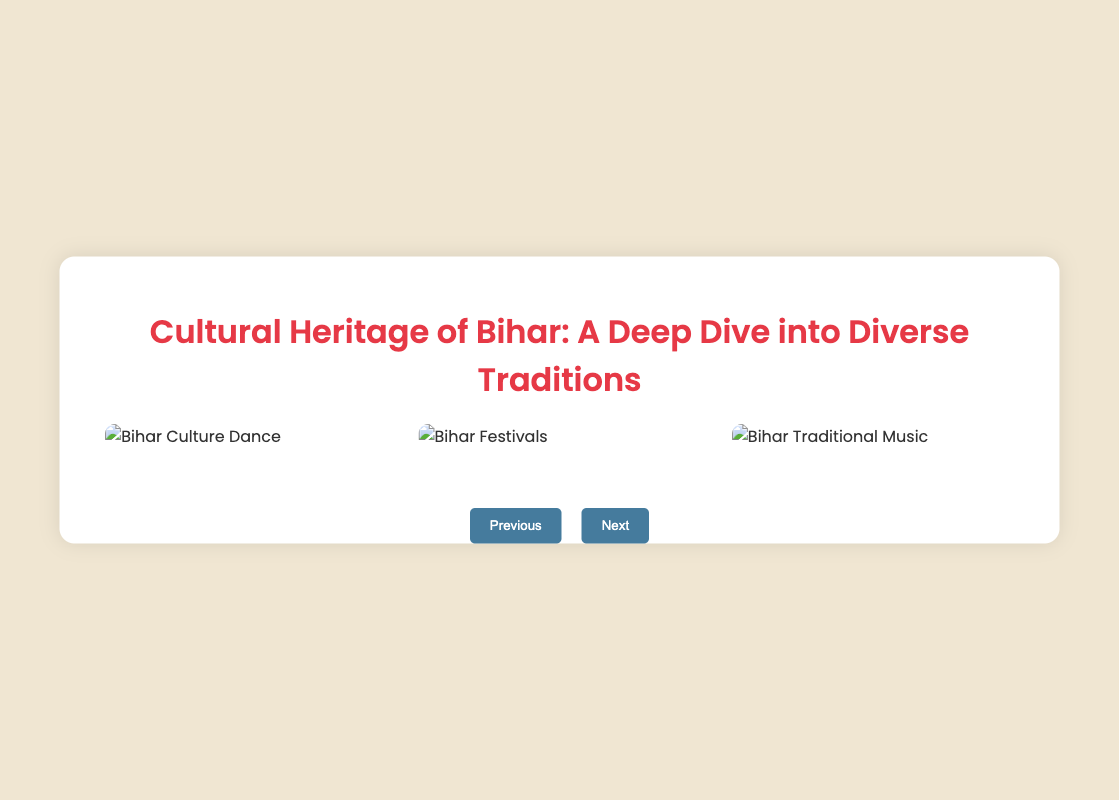what is the title of the presentation? The title of the presentation is the main heading displayed on Slide 1.
Answer: Cultural Heritage of Bihar: A Deep Dive into Diverse Traditions what is a significant historical period mentioned for Bihar? A notable historical period for Bihar listed in Slide 2 is when significant events or influences occurred.
Answer: Medieval Period what festival is dedicated to the Sun God? The festival highlighted in Slide 3 that honors the Sun God is described with its cultural significance.
Answer: Chhath Puja how many slides are in the presentation? The total number of slides is indicated by the structure of the presentation in the coding.
Answer: 5 which cultural landmark is associated with ancient education? The significant cultural landmark related to ancient learning as shown in Slide 4 reflects Bihar's heritage.
Answer: Nalanda University what is a traditional dance form performed during droughts? This dance form is specifically mentioned in Slide 3 and reflects local cultural practices.
Answer: Jhijhiya what organization promotes cultural tourism in Bihar? This organization is tasked with cultural preservation as stated on Slide 5 of the presentation.
Answer: Bihar State Tourism Development Corporation what key date marks the establishment of the Mauryan Empire? This particular date is listed under key historical dates in Slide 2.
Answer: 322 BCE 